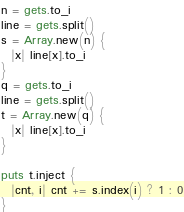<code> <loc_0><loc_0><loc_500><loc_500><_Ruby_>n = gets.to_i
line = gets.split()
s = Array.new(n) {
  |x| line[x].to_i
}
q = gets.to_i
line = gets.split()
t = Array.new(q) {
  |x| line[x].to_i
}

puts t.inject {
  |cnt, i| cnt += s.index(i) ? 1 : 0
}</code> 